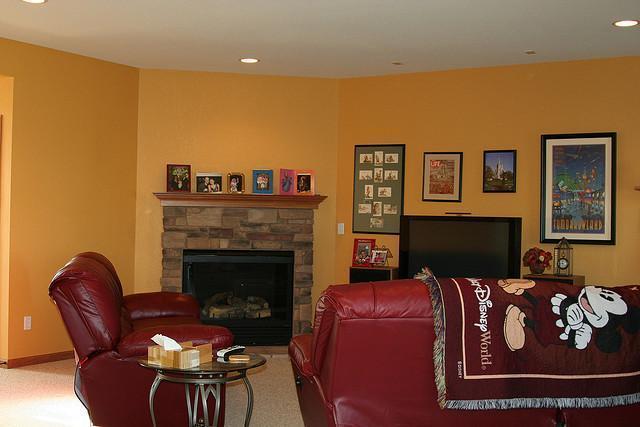How many couches are visible?
Give a very brief answer. 2. 